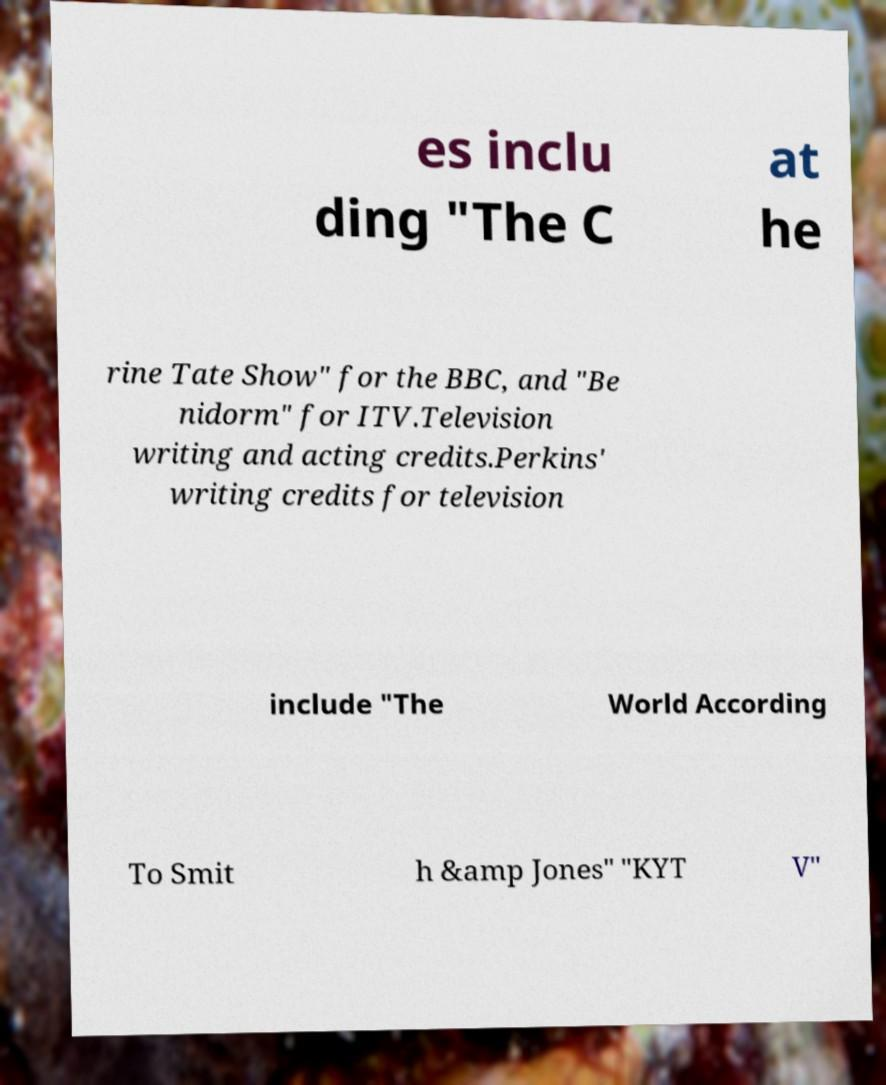There's text embedded in this image that I need extracted. Can you transcribe it verbatim? es inclu ding "The C at he rine Tate Show" for the BBC, and "Be nidorm" for ITV.Television writing and acting credits.Perkins' writing credits for television include "The World According To Smit h &amp Jones" "KYT V" 